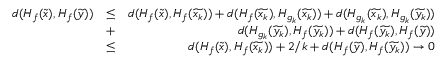Convert formula to latex. <formula><loc_0><loc_0><loc_500><loc_500>\begin{array} { r l r } { d ( H _ { f } ( \widetilde { x } ) , H _ { f } ( \widetilde { y } ) ) } & { \leq } & { d ( H _ { f } ( \widetilde { x } ) , H _ { f } ( \widetilde { x _ { k } } ) ) + d ( H _ { f } ( \widetilde { x _ { k } } ) , H _ { g _ { k } } ( \widetilde { x _ { k } } ) ) + d ( H _ { g _ { k } } ( \widetilde { x _ { k } } ) , H _ { g _ { k } } ( \widetilde { y _ { k } } ) ) } \\ & { + } & { d ( H _ { g _ { k } } ( \widetilde { y _ { k } } ) , H _ { f } ( \widetilde { y _ { k } } ) ) + d ( H _ { f } ( \widetilde { y _ { k } } ) , H _ { f } ( \widetilde { y } ) ) } \\ & { \leq } & { d ( H _ { f } ( \widetilde { x } ) , H _ { f } ( \widetilde { x _ { k } } ) ) + 2 / k + d ( H _ { f } ( \widetilde { y } ) , H _ { f } ( \widetilde { y _ { k } } ) ) \to 0 } \end{array}</formula> 